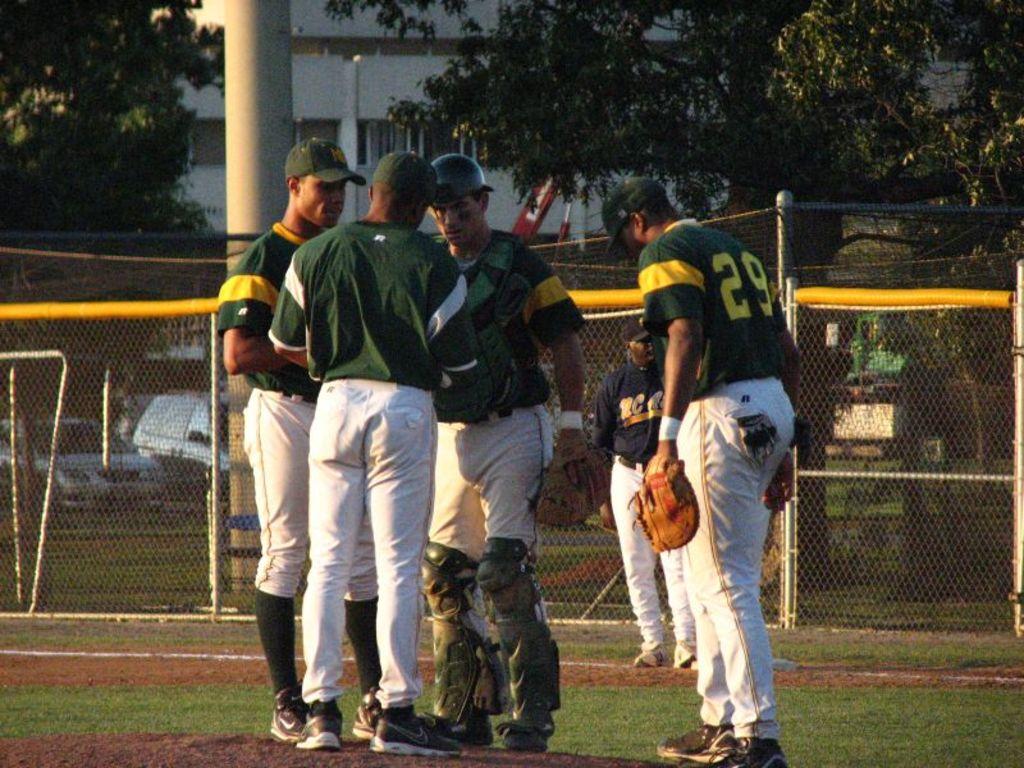What number is on the back of the baseball player's shirt?
Make the answer very short. 29. What is the middle letter on the player with blue shirt?
Provide a succinct answer. C. 